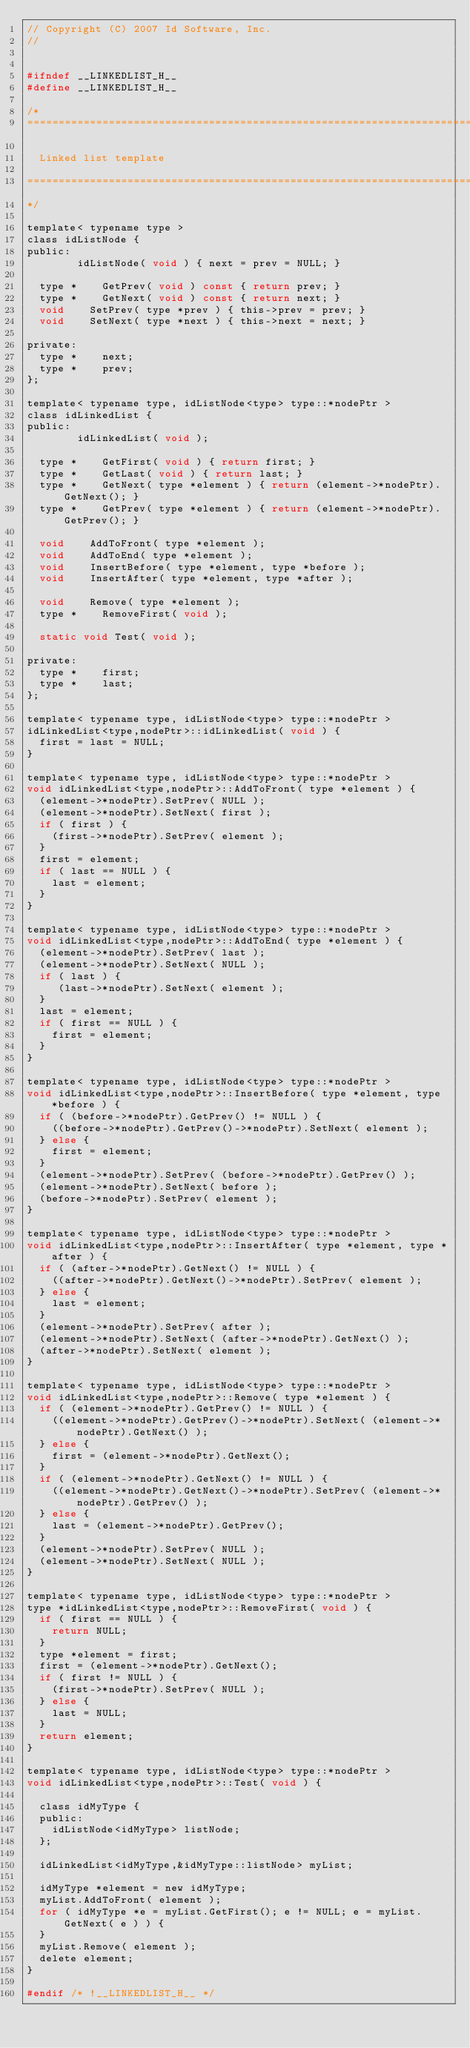<code> <loc_0><loc_0><loc_500><loc_500><_C_>// Copyright (C) 2007 Id Software, Inc.
//


#ifndef __LINKEDLIST_H__
#define __LINKEDLIST_H__

/*
===============================================================================

	Linked list template

===============================================================================
*/

template< typename type >
class idListNode {
public:
				idListNode( void ) { next = prev = NULL; }

	type *		GetPrev( void ) const { return prev; }
	type *		GetNext( void ) const { return next; }
	void		SetPrev( type *prev ) { this->prev = prev; }
	void		SetNext( type *next ) { this->next = next; }

private:
	type *		next;
	type *		prev;
};

template< typename type, idListNode<type> type::*nodePtr >
class idLinkedList {
public:
				idLinkedList( void );

	type *		GetFirst( void ) { return first; }
	type *		GetLast( void ) { return last; }
	type *		GetNext( type *element ) { return (element->*nodePtr).GetNext(); }
	type *		GetPrev( type *element ) { return (element->*nodePtr).GetPrev(); }

	void		AddToFront( type *element );
	void		AddToEnd( type *element );
	void		InsertBefore( type *element, type *before );
	void		InsertAfter( type *element, type *after );

	void		Remove( type *element );
	type *		RemoveFirst( void );

	static void	Test( void );

private:
	type *		first;
	type *		last;
};

template< typename type, idListNode<type> type::*nodePtr >
idLinkedList<type,nodePtr>::idLinkedList( void ) {
	first = last = NULL;
}

template< typename type, idListNode<type> type::*nodePtr >
void idLinkedList<type,nodePtr>::AddToFront( type *element ) {
	(element->*nodePtr).SetPrev( NULL );
	(element->*nodePtr).SetNext( first );
	if ( first ) {
		(first->*nodePtr).SetPrev( element );
	}
	first = element;
	if ( last == NULL ) {
		last = element;
	}
}

template< typename type, idListNode<type> type::*nodePtr >
void idLinkedList<type,nodePtr>::AddToEnd( type *element ) {
	(element->*nodePtr).SetPrev( last );
	(element->*nodePtr).SetNext( NULL );
	if ( last ) {
	   (last->*nodePtr).SetNext( element );
	}
	last = element;
	if ( first == NULL ) {
		first = element;
	}
}

template< typename type, idListNode<type> type::*nodePtr >
void idLinkedList<type,nodePtr>::InsertBefore( type *element, type *before ) {
	if ( (before->*nodePtr).GetPrev() != NULL ) {
		((before->*nodePtr).GetPrev()->*nodePtr).SetNext( element );
	} else {
		first = element;
	}
	(element->*nodePtr).SetPrev( (before->*nodePtr).GetPrev() );
	(element->*nodePtr).SetNext( before );
	(before->*nodePtr).SetPrev( element );
}

template< typename type, idListNode<type> type::*nodePtr >
void idLinkedList<type,nodePtr>::InsertAfter( type *element, type *after ) {
	if ( (after->*nodePtr).GetNext() != NULL ) {
		((after->*nodePtr).GetNext()->*nodePtr).SetPrev( element );
	} else {
		last = element;
	}
	(element->*nodePtr).SetPrev( after );
	(element->*nodePtr).SetNext( (after->*nodePtr).GetNext() );
	(after->*nodePtr).SetNext( element );
}

template< typename type, idListNode<type> type::*nodePtr >
void idLinkedList<type,nodePtr>::Remove( type *element ) {
	if ( (element->*nodePtr).GetPrev() != NULL ) {
		((element->*nodePtr).GetPrev()->*nodePtr).SetNext( (element->*nodePtr).GetNext() );
	} else {
		first = (element->*nodePtr).GetNext();
	}
	if ( (element->*nodePtr).GetNext() != NULL ) {
		((element->*nodePtr).GetNext()->*nodePtr).SetPrev( (element->*nodePtr).GetPrev() );
	} else {
		last = (element->*nodePtr).GetPrev();
	}
	(element->*nodePtr).SetPrev( NULL );
	(element->*nodePtr).SetNext( NULL );
}

template< typename type, idListNode<type> type::*nodePtr >
type *idLinkedList<type,nodePtr>::RemoveFirst( void ) {
	if ( first == NULL ) {
		return NULL;
	}
	type *element = first;
	first = (element->*nodePtr).GetNext();
	if ( first != NULL ) {
		(first->*nodePtr).SetPrev( NULL );
	} else {
		last = NULL;
	}
	return element;
}

template< typename type, idListNode<type> type::*nodePtr >
void idLinkedList<type,nodePtr>::Test( void ) {

	class idMyType {
	public:
		idListNode<idMyType> listNode;
	};

	idLinkedList<idMyType,&idMyType::listNode> myList;

	idMyType *element = new idMyType;
	myList.AddToFront( element );
	for ( idMyType *e = myList.GetFirst(); e != NULL; e = myList.GetNext( e ) ) {
	}
	myList.Remove( element );
	delete element;
}

#endif /* !__LINKEDLIST_H__ */
</code> 